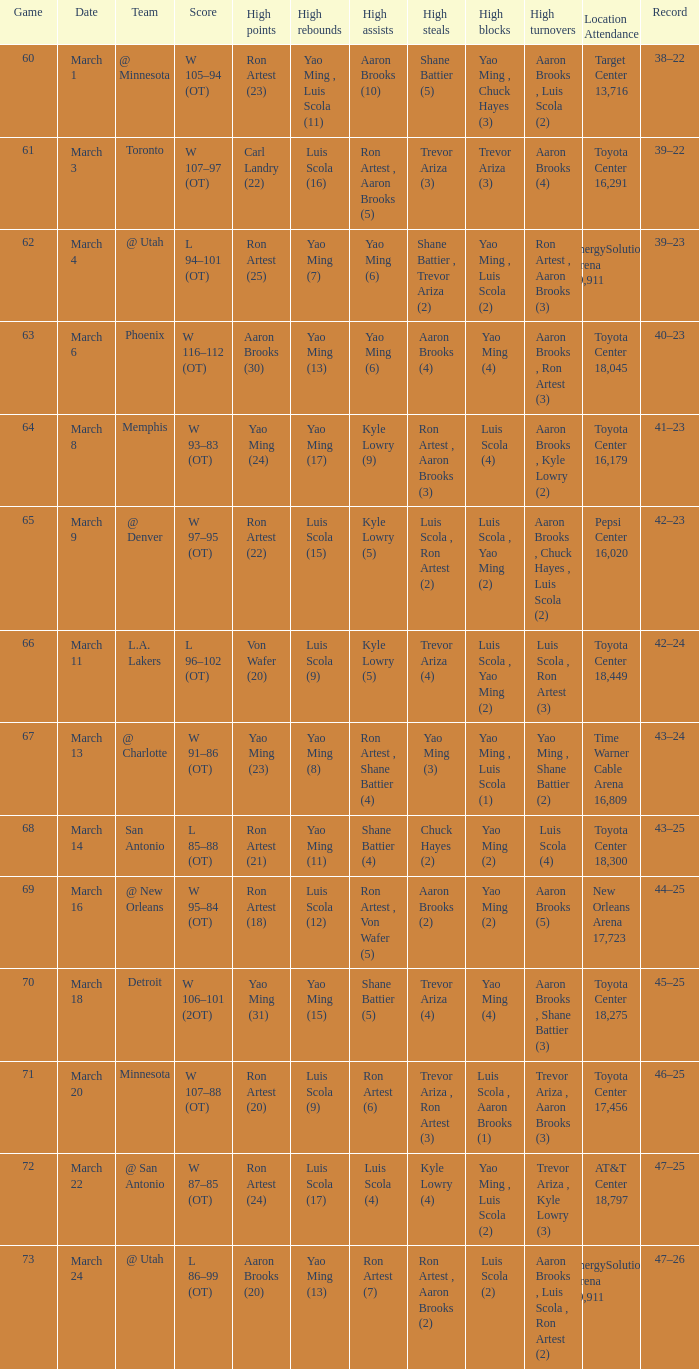On what date did the Rockets play Memphis? March 8. 